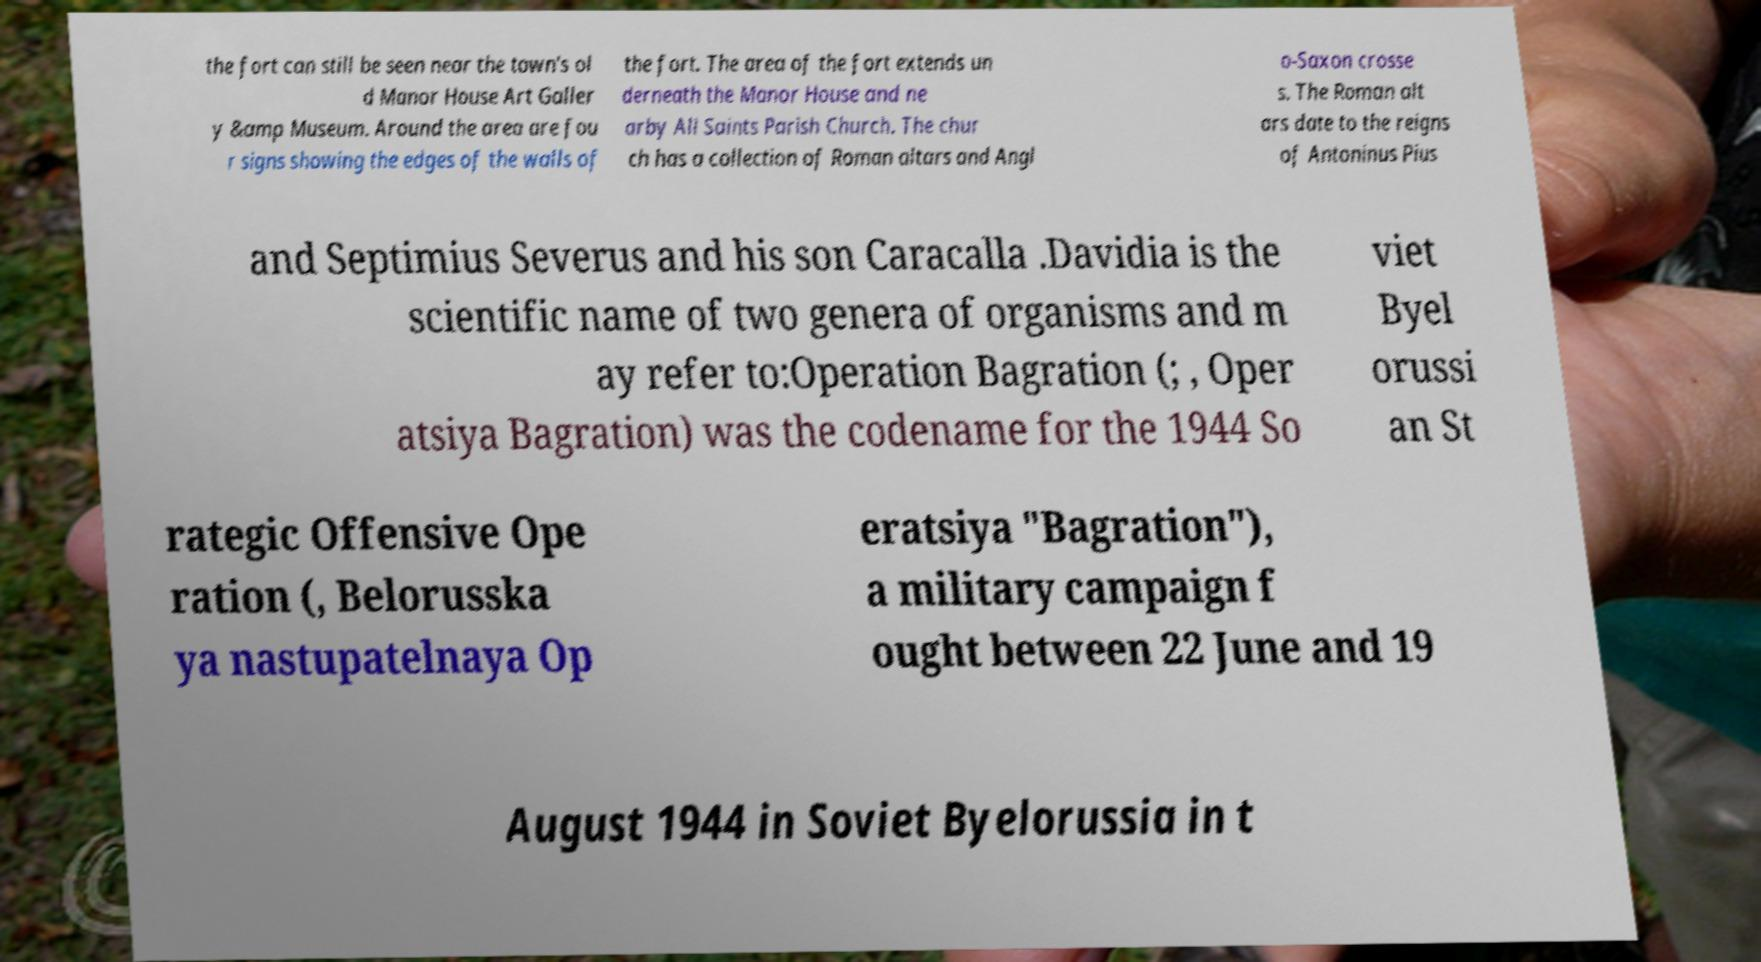What messages or text are displayed in this image? I need them in a readable, typed format. the fort can still be seen near the town's ol d Manor House Art Galler y &amp Museum. Around the area are fou r signs showing the edges of the walls of the fort. The area of the fort extends un derneath the Manor House and ne arby All Saints Parish Church. The chur ch has a collection of Roman altars and Angl o-Saxon crosse s. The Roman alt ars date to the reigns of Antoninus Pius and Septimius Severus and his son Caracalla .Davidia is the scientific name of two genera of organisms and m ay refer to:Operation Bagration (; , Oper atsiya Bagration) was the codename for the 1944 So viet Byel orussi an St rategic Offensive Ope ration (, Belorusska ya nastupatelnaya Op eratsiya "Bagration"), a military campaign f ought between 22 June and 19 August 1944 in Soviet Byelorussia in t 